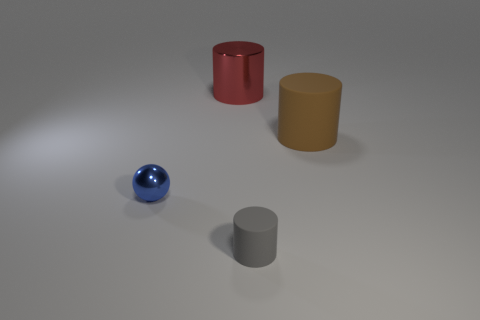Add 3 gray matte cylinders. How many objects exist? 7 Subtract all brown rubber cylinders. Subtract all large red shiny objects. How many objects are left? 2 Add 1 tiny blue shiny objects. How many tiny blue shiny objects are left? 2 Add 3 shiny things. How many shiny things exist? 5 Subtract all large shiny cylinders. How many cylinders are left? 2 Subtract 1 brown cylinders. How many objects are left? 3 Subtract all cylinders. How many objects are left? 1 Subtract 1 spheres. How many spheres are left? 0 Subtract all green cylinders. Subtract all gray cubes. How many cylinders are left? 3 Subtract all brown balls. How many blue cylinders are left? 0 